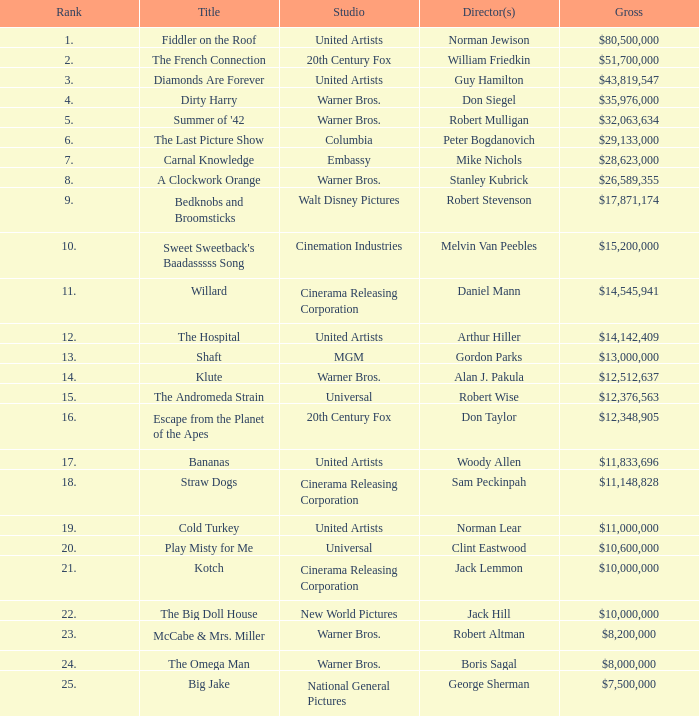Which title with a rank under 19 has a total income of $11,833,696? Bananas. 